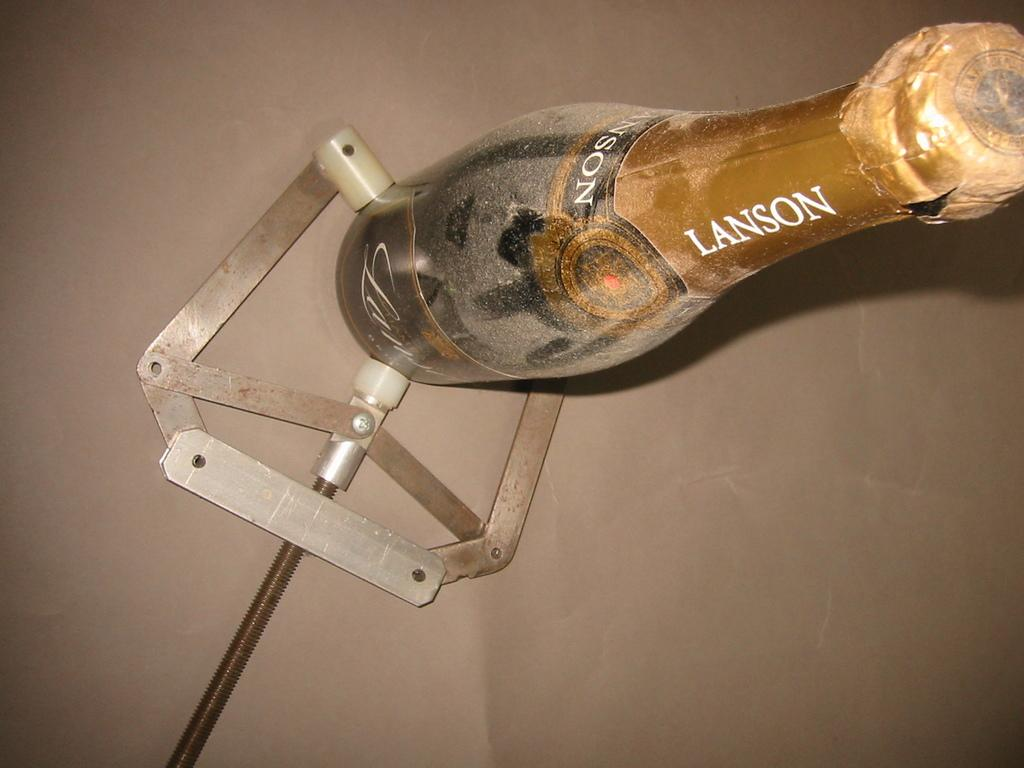What object can be seen in the image? There is a tool in the image. Where is the tool located? The tool is placed on a surface. What is the tool doing in the image? The tool is holding a bottle. What type of ring is the aunt wearing in the image? There is no ring or aunt present in the image; it only features a tool holding a bottle. 